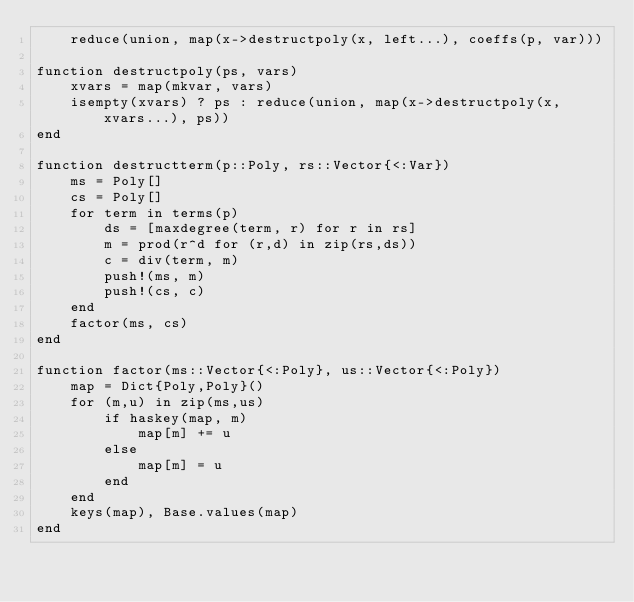<code> <loc_0><loc_0><loc_500><loc_500><_Julia_>    reduce(union, map(x->destructpoly(x, left...), coeffs(p, var)))

function destructpoly(ps, vars)
    xvars = map(mkvar, vars)
    isempty(xvars) ? ps : reduce(union, map(x->destructpoly(x, xvars...), ps))
end

function destructterm(p::Poly, rs::Vector{<:Var})
    ms = Poly[]
    cs = Poly[]
    for term in terms(p)
        ds = [maxdegree(term, r) for r in rs]
        m = prod(r^d for (r,d) in zip(rs,ds))
        c = div(term, m)
        push!(ms, m)
        push!(cs, c)
    end
    factor(ms, cs)
end

function factor(ms::Vector{<:Poly}, us::Vector{<:Poly})
    map = Dict{Poly,Poly}()
    for (m,u) in zip(ms,us)
        if haskey(map, m)
            map[m] += u
        else
            map[m] = u
        end
    end
    keys(map), Base.values(map)
end
</code> 